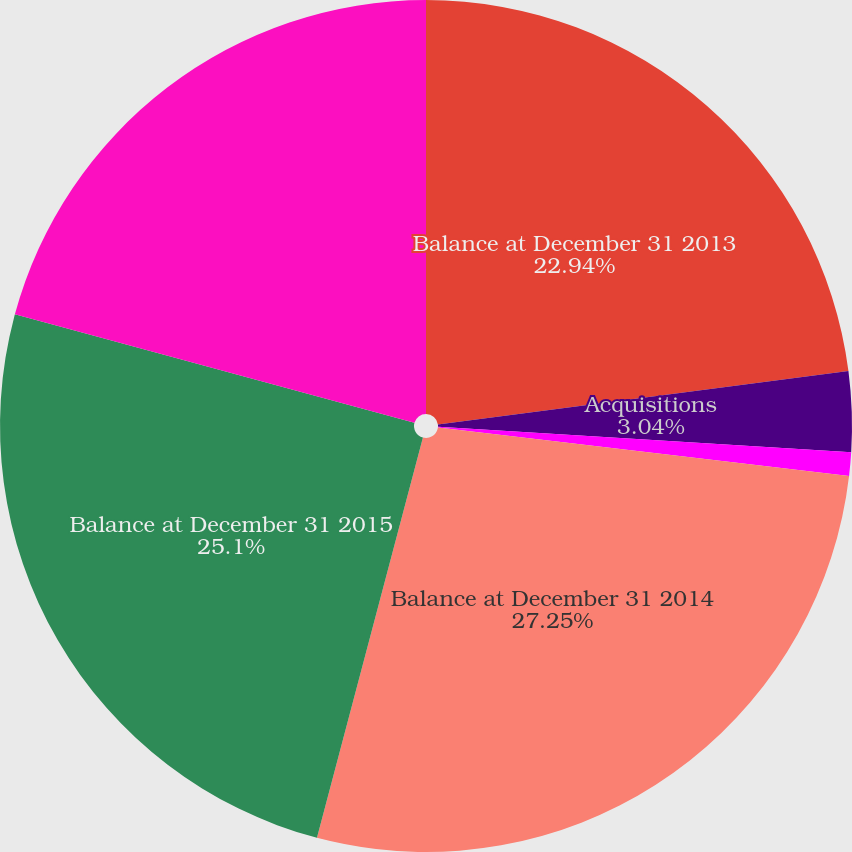Convert chart to OTSL. <chart><loc_0><loc_0><loc_500><loc_500><pie_chart><fcel>Balance at December 31 2013<fcel>Acquisitions<fcel>Foreign currency translation<fcel>Balance at December 31 2014<fcel>Balance at December 31 2015<fcel>Balance at December 31 2016<nl><fcel>22.94%<fcel>3.04%<fcel>0.89%<fcel>27.25%<fcel>25.1%<fcel>20.78%<nl></chart> 